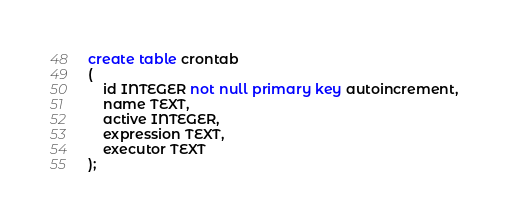<code> <loc_0><loc_0><loc_500><loc_500><_SQL_>create table crontab
(
	id INTEGER not null primary key autoincrement,
	name TEXT,
	active INTEGER,
	expression TEXT,
	executor TEXT
);
</code> 